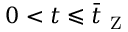<formula> <loc_0><loc_0><loc_500><loc_500>0 < t \leqslant \bar { t } _ { Z }</formula> 